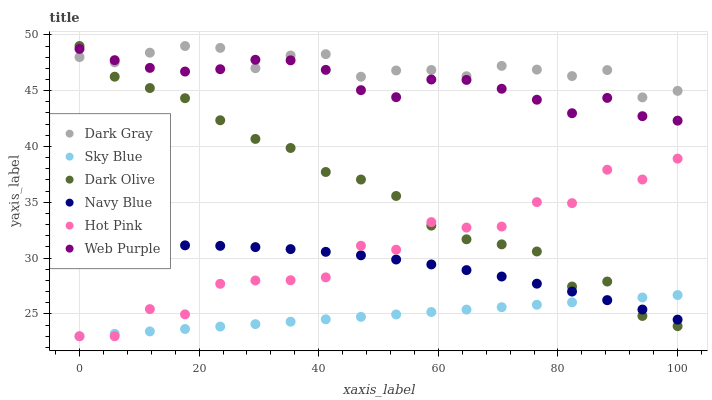Does Sky Blue have the minimum area under the curve?
Answer yes or no. Yes. Does Dark Gray have the maximum area under the curve?
Answer yes or no. Yes. Does Navy Blue have the minimum area under the curve?
Answer yes or no. No. Does Navy Blue have the maximum area under the curve?
Answer yes or no. No. Is Sky Blue the smoothest?
Answer yes or no. Yes. Is Hot Pink the roughest?
Answer yes or no. Yes. Is Navy Blue the smoothest?
Answer yes or no. No. Is Navy Blue the roughest?
Answer yes or no. No. Does Hot Pink have the lowest value?
Answer yes or no. Yes. Does Navy Blue have the lowest value?
Answer yes or no. No. Does Dark Gray have the highest value?
Answer yes or no. Yes. Does Navy Blue have the highest value?
Answer yes or no. No. Is Hot Pink less than Web Purple?
Answer yes or no. Yes. Is Web Purple greater than Navy Blue?
Answer yes or no. Yes. Does Navy Blue intersect Dark Olive?
Answer yes or no. Yes. Is Navy Blue less than Dark Olive?
Answer yes or no. No. Is Navy Blue greater than Dark Olive?
Answer yes or no. No. Does Hot Pink intersect Web Purple?
Answer yes or no. No. 